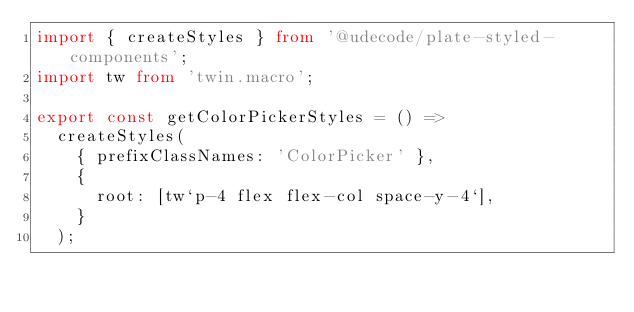<code> <loc_0><loc_0><loc_500><loc_500><_TypeScript_>import { createStyles } from '@udecode/plate-styled-components';
import tw from 'twin.macro';

export const getColorPickerStyles = () =>
  createStyles(
    { prefixClassNames: 'ColorPicker' },
    {
      root: [tw`p-4 flex flex-col space-y-4`],
    }
  );
</code> 